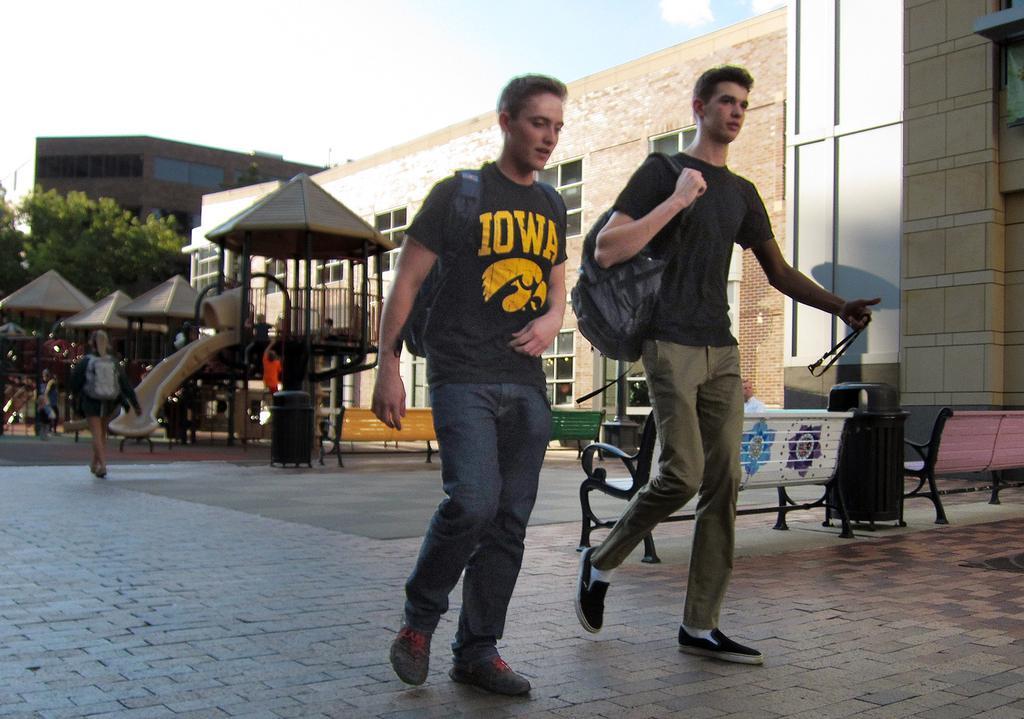Could you give a brief overview of what you see in this image? In the center of the image we can see two persons are walking and they are wearing bags. And the right side person is holding some object. In the background, we can see the sky, clouds, buildings, trees, sheds, few people and a few other objects. 